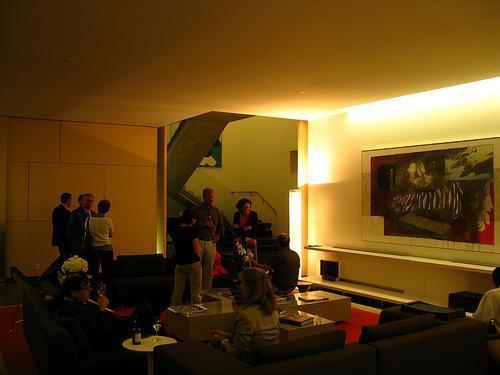How many bottles of wine are visible?
Give a very brief answer. 1. How many pieces of wall art are there?
Give a very brief answer. 1. 